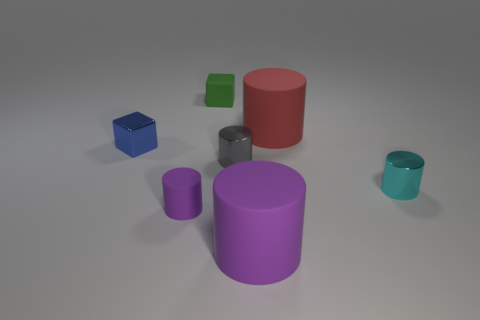How many objects are either big yellow balls or green rubber objects?
Make the answer very short. 1. There is a matte block that is the same size as the blue shiny block; what color is it?
Offer a terse response. Green. What number of things are cylinders that are in front of the matte block or yellow metallic cubes?
Your answer should be very brief. 5. How many other objects are the same size as the blue object?
Keep it short and to the point. 4. How big is the matte cylinder behind the blue block?
Offer a terse response. Large. There is a small blue thing that is made of the same material as the small gray thing; what is its shape?
Offer a terse response. Cube. Is there anything else of the same color as the tiny rubber cylinder?
Provide a succinct answer. Yes. There is a tiny object to the left of the purple cylinder that is on the left side of the large purple object; what color is it?
Your answer should be very brief. Blue. How many large things are either cylinders or purple rubber objects?
Ensure brevity in your answer.  2. There is a tiny gray thing that is the same shape as the small cyan object; what is it made of?
Your answer should be compact. Metal. 